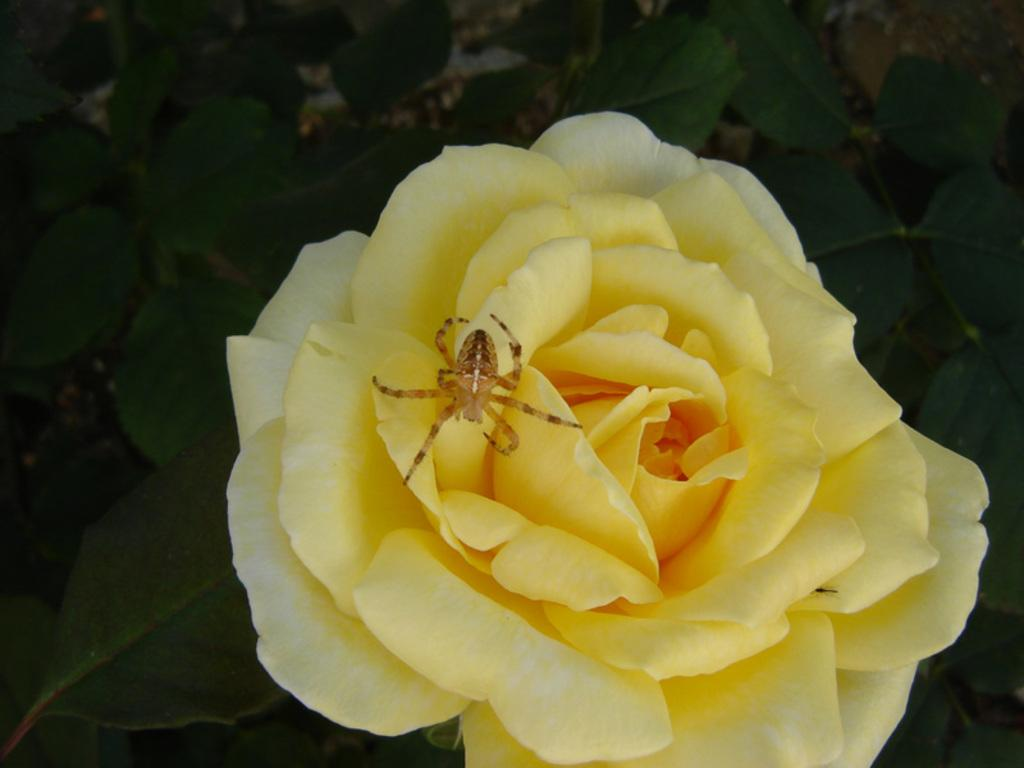What is present on the rose flower in the image? There is an insect on the rose flower in the image. Can you describe the insect's location on the flower? The insect is on the rose flower in the image. What shape is the key in the image? There is no key present in the image; it features an insect on a rose flower. 